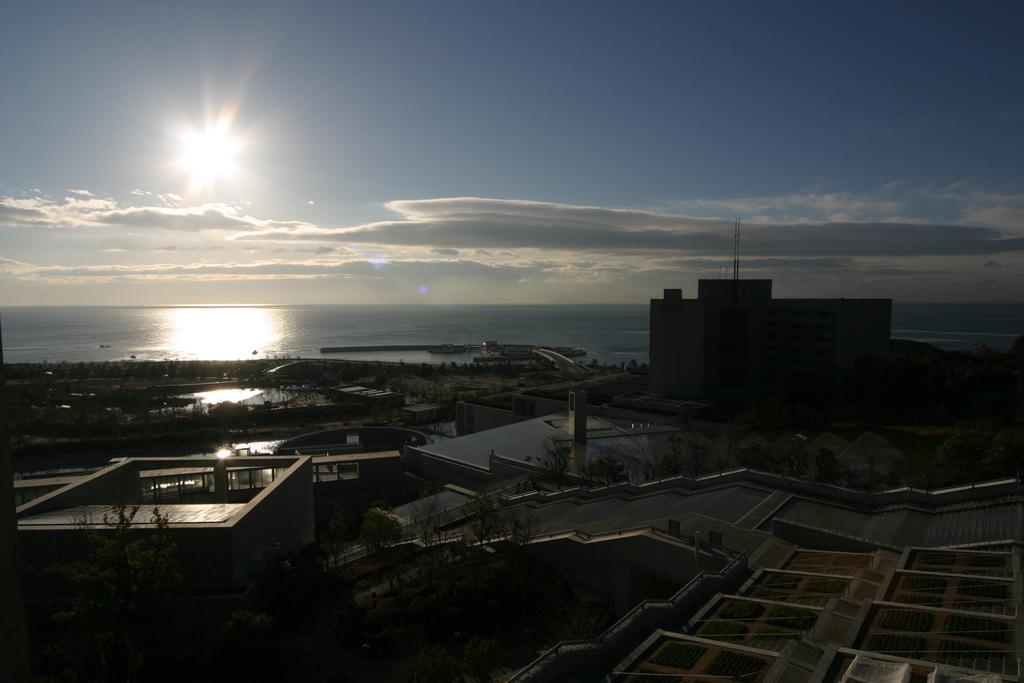Can you describe this image briefly? In this image we can see some houses, trees and in the background of the image there is water and clear sky. 